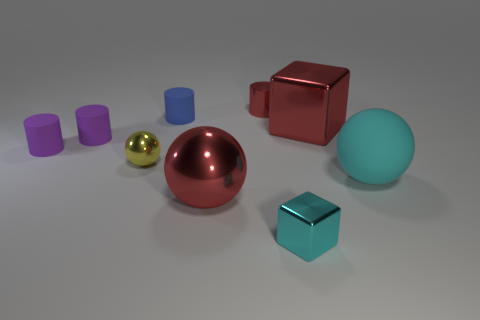Subtract all cubes. How many objects are left? 7 Add 1 rubber things. How many rubber things are left? 5 Add 8 yellow objects. How many yellow objects exist? 9 Subtract 0 gray cylinders. How many objects are left? 9 Subtract all big shiny things. Subtract all tiny green metal things. How many objects are left? 7 